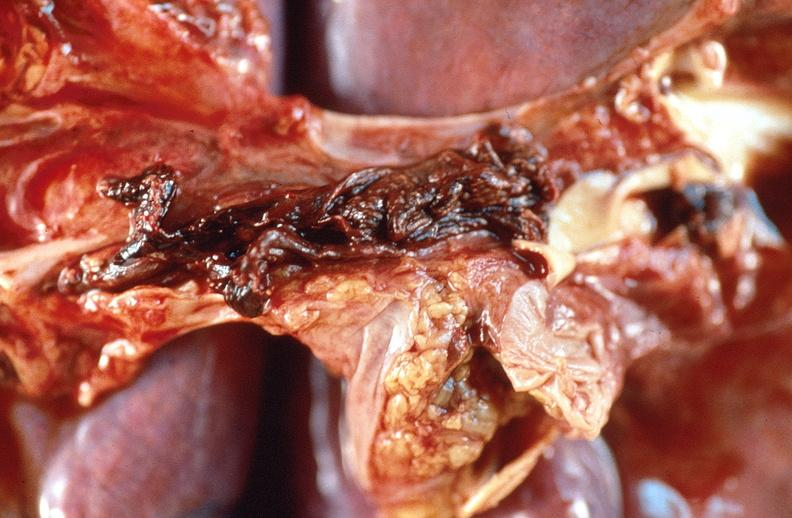does this image show pulmonary thromboemboli?
Answer the question using a single word or phrase. Yes 